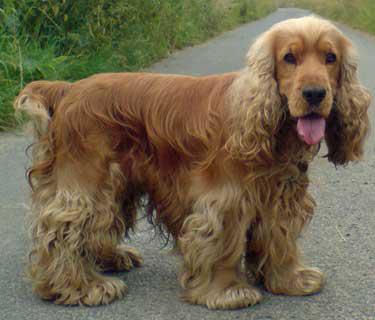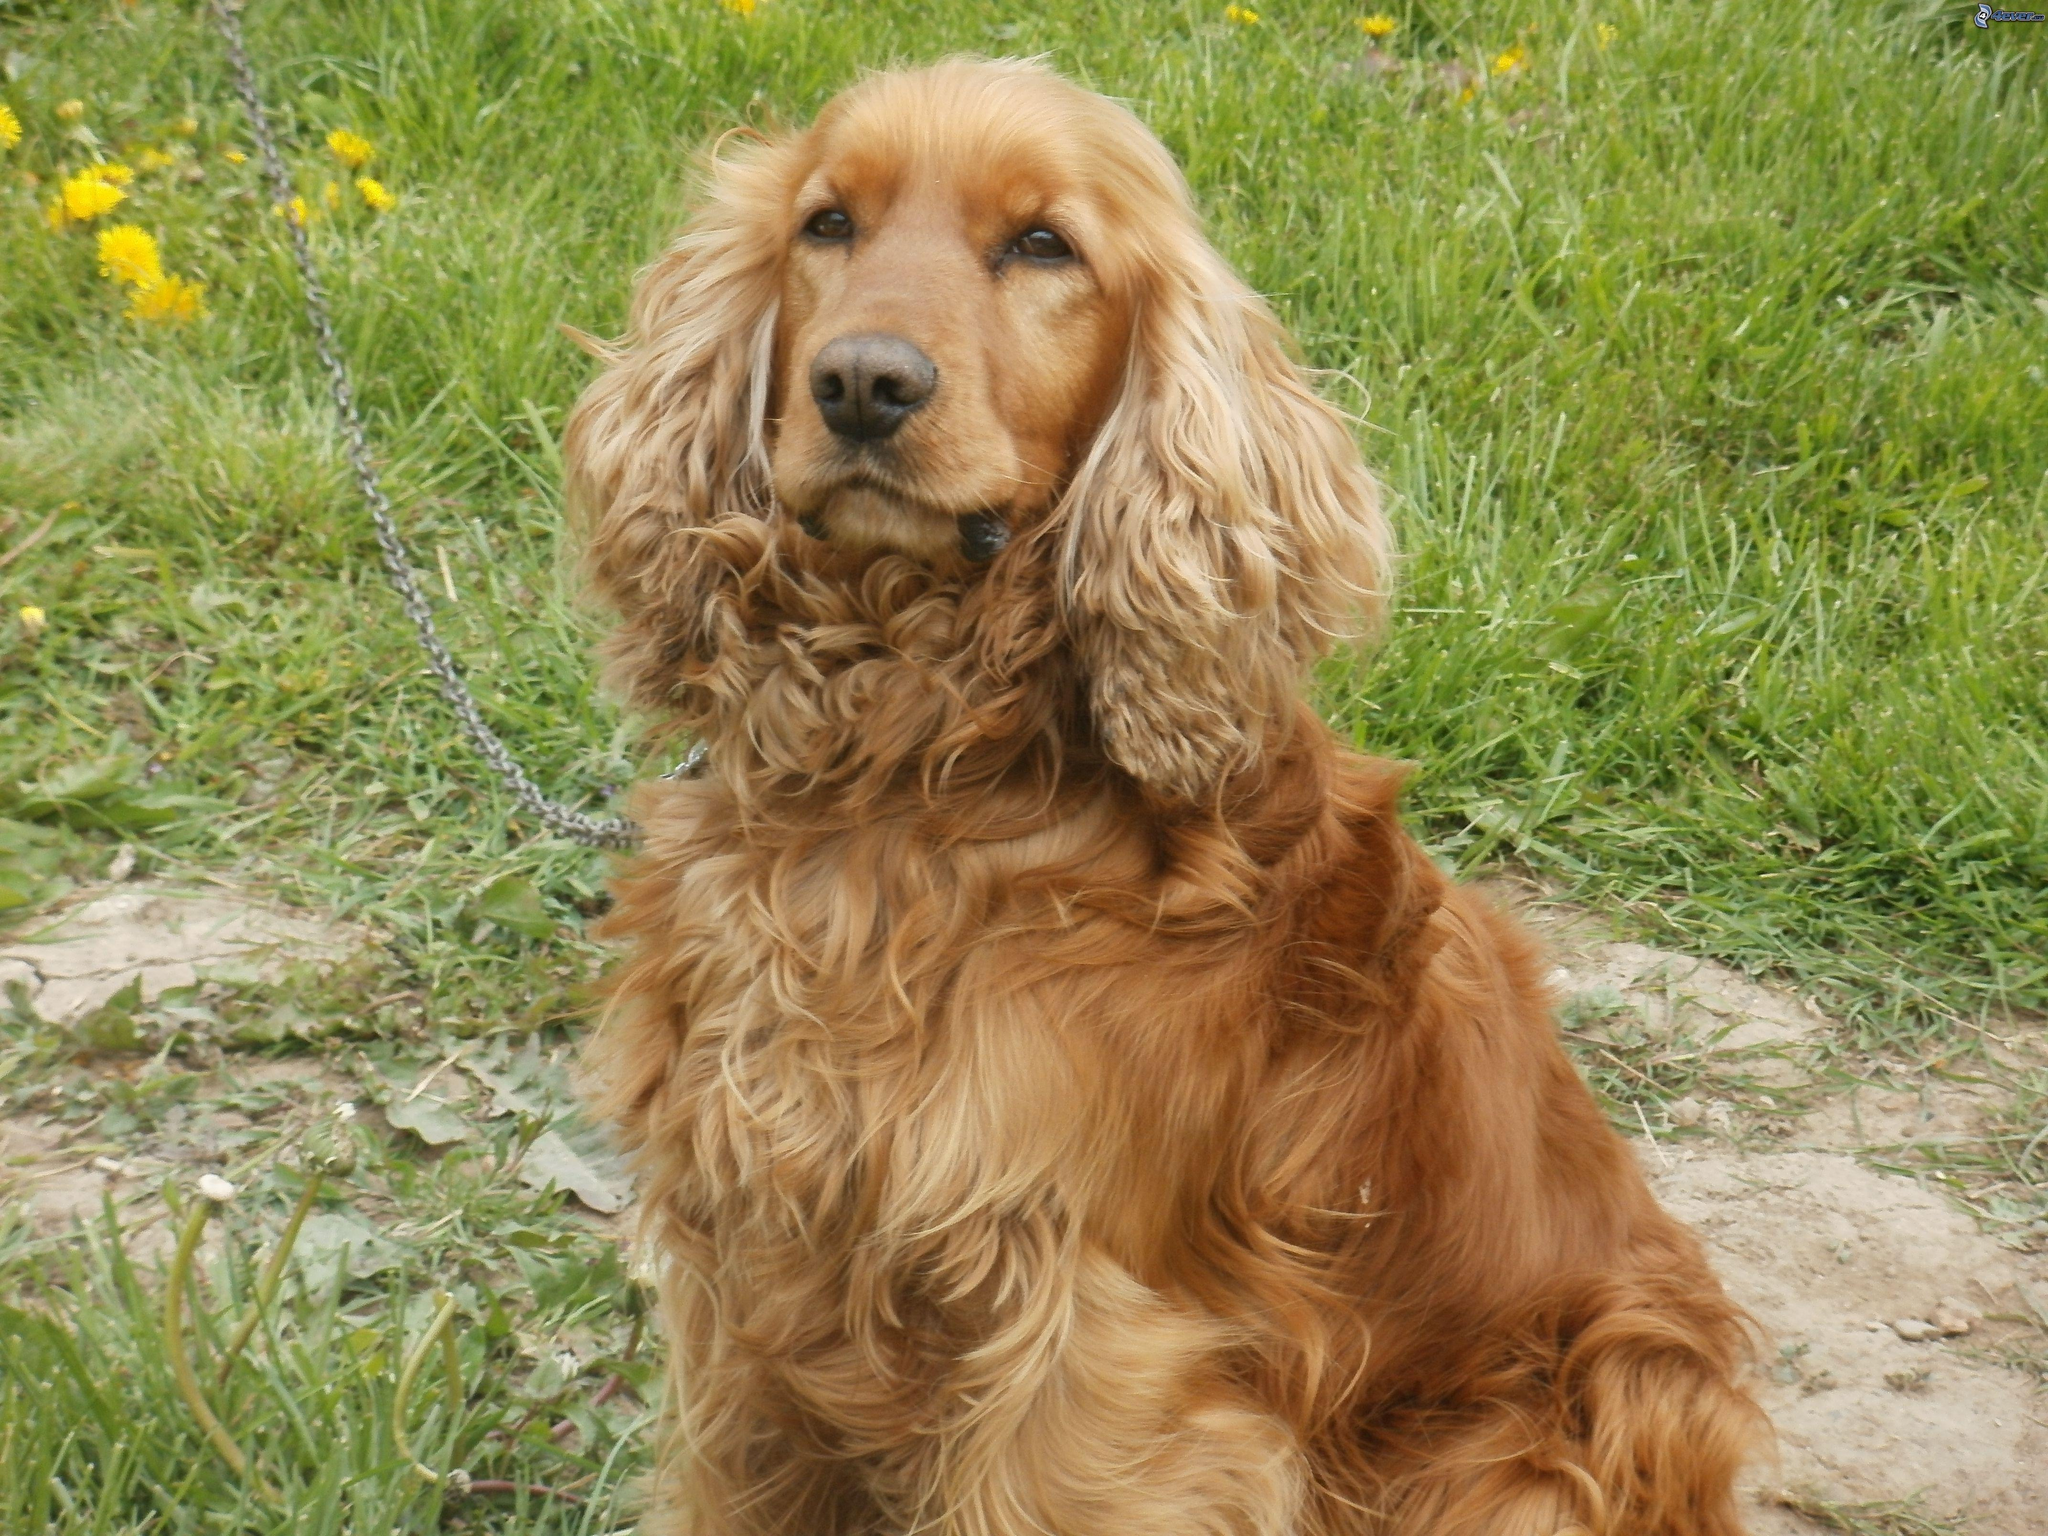The first image is the image on the left, the second image is the image on the right. Considering the images on both sides, is "In one of the images the dog is lying down." valid? Answer yes or no. No. 